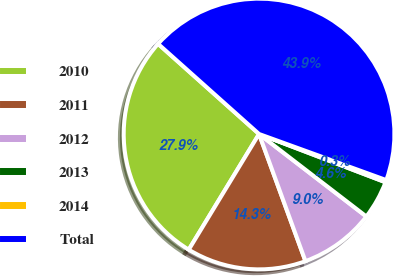Convert chart to OTSL. <chart><loc_0><loc_0><loc_500><loc_500><pie_chart><fcel>2010<fcel>2011<fcel>2012<fcel>2013<fcel>2014<fcel>Total<nl><fcel>27.91%<fcel>14.26%<fcel>9.0%<fcel>4.63%<fcel>0.27%<fcel>43.93%<nl></chart> 